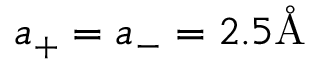<formula> <loc_0><loc_0><loc_500><loc_500>a _ { + } = a _ { - } = 2 . 5 \mathring { A }</formula> 